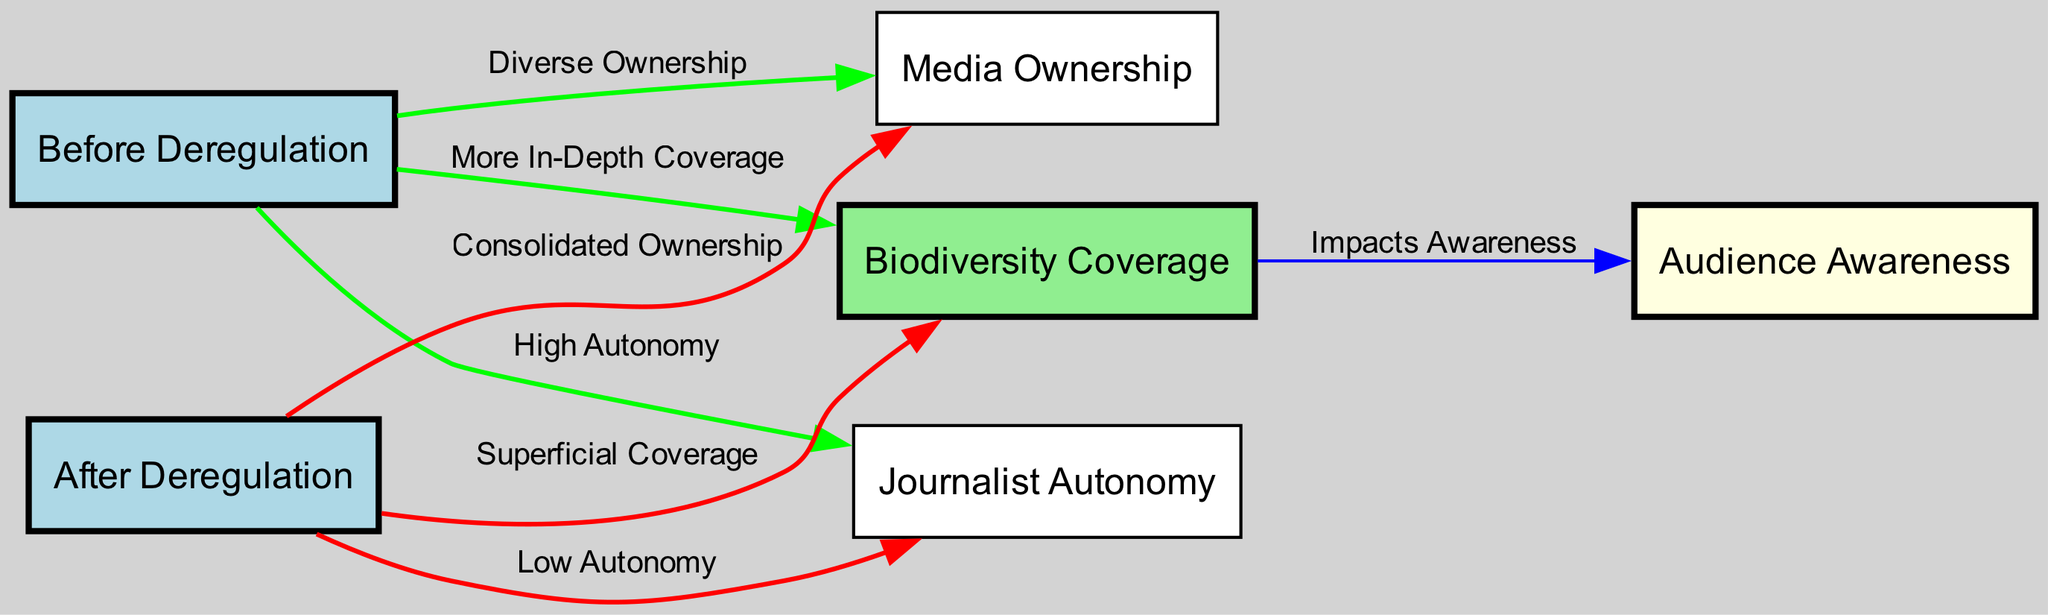How many nodes are in the diagram? The diagram contains six distinct nodes, which are: Before Deregulation, After Deregulation, Biodiversity Coverage, Media Ownership, Journalist Autonomy, and Audience Awareness.
Answer: 6 What are the two states of biodiversity coverage before and after deregulation? Before deregulation, biodiversity coverage is labeled as "More In-Depth Coverage," and after deregulation, it changes to "Superficial Coverage."
Answer: More In-Depth Coverage, Superficial Coverage What relationship does 'Before Deregulation' have with 'Media Ownership'? The edge shows that before deregulation, the relationship indicates "Diverse Ownership" pointing from 'Before Deregulation' to 'Media Ownership.'
Answer: Diverse Ownership What is the impact of Biodiversity Coverage on Audience Awareness? According to the diagram, the impact is labeled as "Impacts Awareness," indicating that biodiversity coverage directly influences audience awareness.
Answer: Impacts Awareness What changes occur to journalist autonomy as a result of media deregulation? The diagram indicates that journalist autonomy changes from "High Autonomy" before deregulation to "Low Autonomy" after deregulation, reflecting a notable decrease.
Answer: Low Autonomy How does media ownership shift after deregulation? The edge shows that after deregulation, media ownership shifts from a state of "Diverse Ownership" to "Consolidated Ownership," indicating a centralization of media resources.
Answer: Consolidated Ownership What color represents the 'Biodiversity Coverage' node? The node labeled 'Biodiversity Coverage' is filled with light green color in the diagram, which visually distinguishes it from other nodes.
Answer: Light green What is the overall trend in biodiversity coverage from pre to post deregulation in the diagram? The trend indicates a decline in the quality of biodiversity coverage, moving from in-depth coverage to a superficial form after deregulation.
Answer: Decline in quality What type of ownership is represented in the post-deregulation scenario? The post-deregulation scenario depicts "Consolidated Ownership," suggesting a less diverse media landscape.
Answer: Consolidated Ownership 